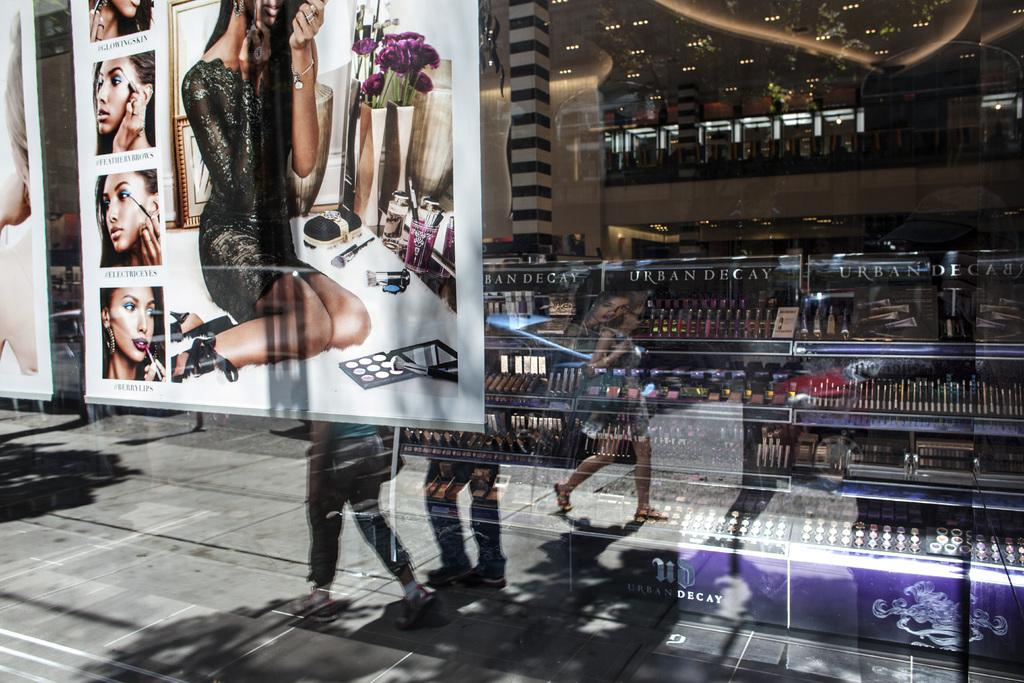What structures can be seen in the image? There are posts, a pillar, and a ceiling visible in the image. Who or what is present in the image? There are people in the image. What type of establishment is depicted in the image? There is a store in the image. What material is present in the image? There is glass and lights visible in the image. What type of hat is being sold in the store in the image? There is no hat visible in the image, nor is there any indication that a hat is being sold in the store. What flavor of jam can be seen on the shelf in the image? There is no jam present in the image. 